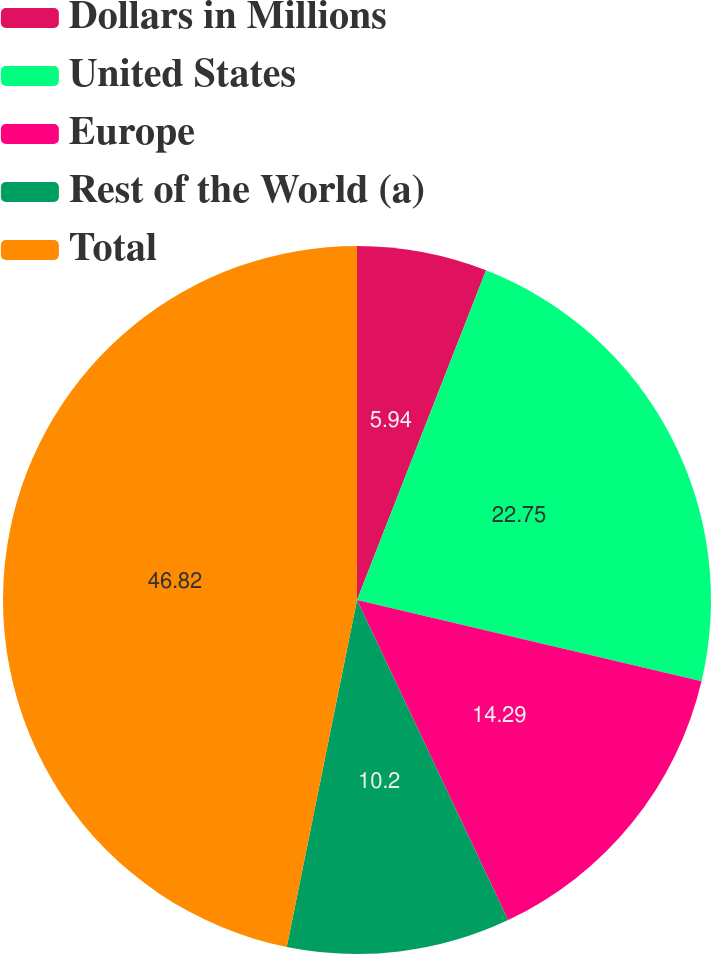Convert chart to OTSL. <chart><loc_0><loc_0><loc_500><loc_500><pie_chart><fcel>Dollars in Millions<fcel>United States<fcel>Europe<fcel>Rest of the World (a)<fcel>Total<nl><fcel>5.94%<fcel>22.75%<fcel>14.29%<fcel>10.2%<fcel>46.82%<nl></chart> 